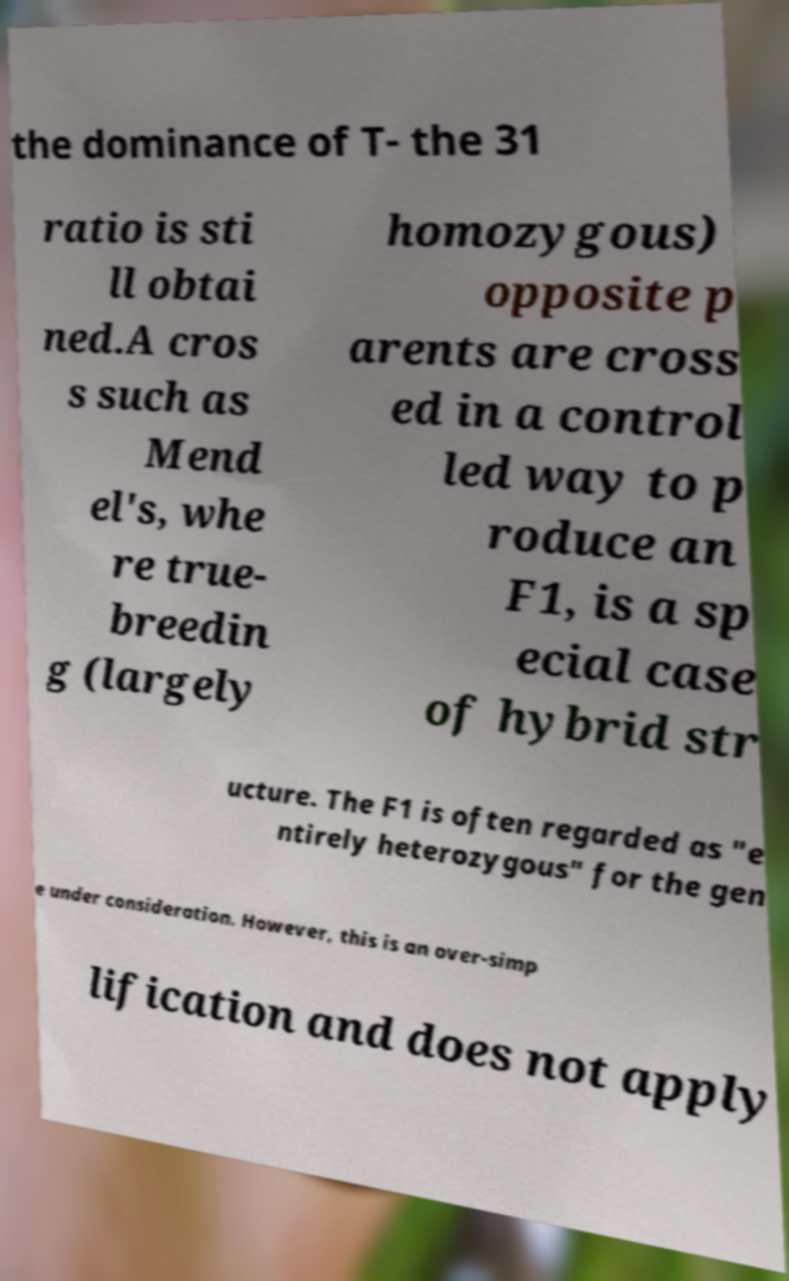Can you read and provide the text displayed in the image?This photo seems to have some interesting text. Can you extract and type it out for me? the dominance of T- the 31 ratio is sti ll obtai ned.A cros s such as Mend el's, whe re true- breedin g (largely homozygous) opposite p arents are cross ed in a control led way to p roduce an F1, is a sp ecial case of hybrid str ucture. The F1 is often regarded as "e ntirely heterozygous" for the gen e under consideration. However, this is an over-simp lification and does not apply 